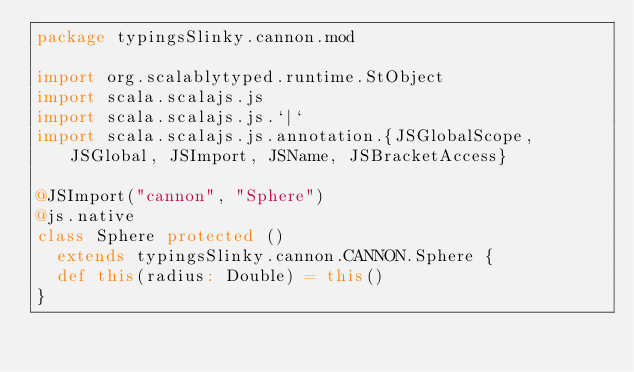Convert code to text. <code><loc_0><loc_0><loc_500><loc_500><_Scala_>package typingsSlinky.cannon.mod

import org.scalablytyped.runtime.StObject
import scala.scalajs.js
import scala.scalajs.js.`|`
import scala.scalajs.js.annotation.{JSGlobalScope, JSGlobal, JSImport, JSName, JSBracketAccess}

@JSImport("cannon", "Sphere")
@js.native
class Sphere protected ()
  extends typingsSlinky.cannon.CANNON.Sphere {
  def this(radius: Double) = this()
}
</code> 